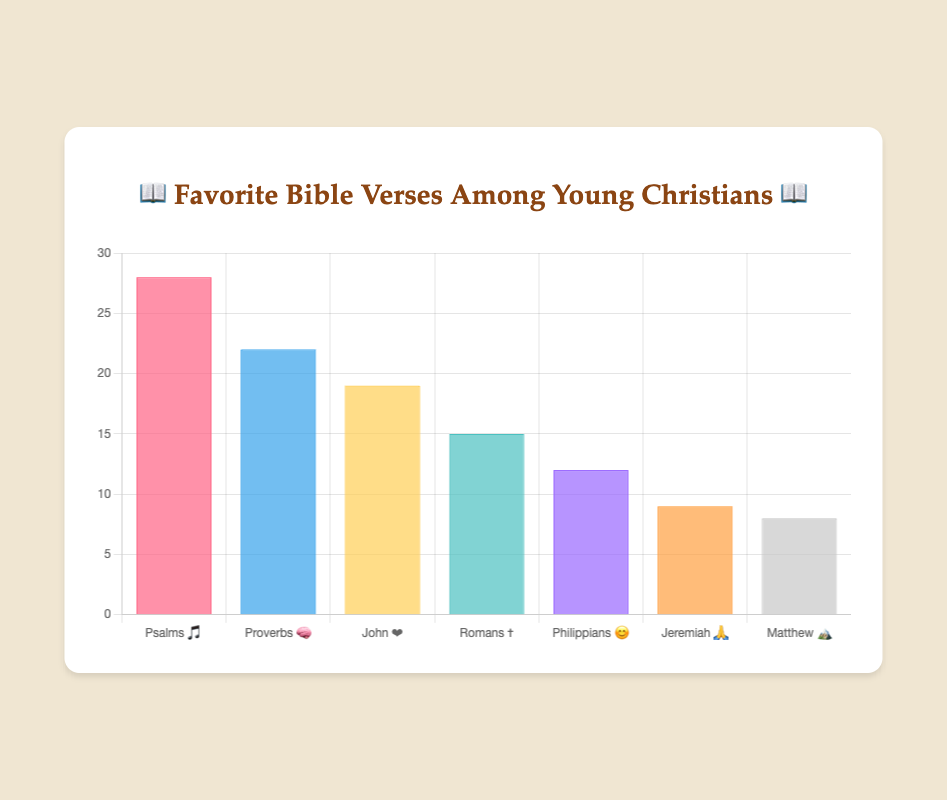Which book has the most favorite verses among young Christians? The book with the highest value on the chart represents the book with the most favorite verses. Psalms has the highest bar with 28 favorite verses.
Answer: Psalms 🎵 How many more favorite verses does Psalms have compared to Proverbs? Find the value for Psalms (28) and subtract the value for Proverbs (22). The difference is 28 - 22 = 6.
Answer: 6 Which book has the fewest favorite verses among the listed books? Identify the book with the shortest bar in the chart. Matthew has the shortest bar with 8 favorite verses.
Answer: Matthew 🏔️ What is the combined total of favorite verses for John and Romans? Look at the number of favorite verses for John (19) and Romans (15), then add them together. The combined total is 19 + 15 = 34.
Answer: 34 Is the number of favorite verses for Philippians closer to the number of favorite verses for Jeremiah or Matthew? Compare the difference between Philippians (12) and Jeremiah (9), and Philippians (12) and Matthew (8). The differences are 12 - 9 = 3 and 12 - 8 = 4. Philippians is closer to Jeremiah.
Answer: Jeremiah 🙏 What is the average number of favorite verses for all the listed books? Add up all the values (28 + 22 + 19 + 15 + 12 + 9 + 8) and divide by the number of books (7). The sum is 113, and the average is 113 / 7 = 16.14.
Answer: 16.14 Does Proverbs have more than twice the number of favorite verses as Matthew? Compare two times the value of Matthew (2 * 8 = 16) with the value of Proverbs (22). Proverbs (22) is greater than 16, so it has more than twice the favorite verses.
Answer: Yes Which two books have the same second and third highest number of favorite verses? Identify the second (Proverbs with 22) and third (John with 19) highest bars in the chart.
Answer: Proverbs 🧠 and John ❤️ What is the difference in the number of favorite verses between the book with the highest and lowest values? Subtract the number of favorite verses of the lowest book (Matthew with 8) from the highest (Psalms with 28). The difference is 28 - 8 = 20.
Answer: 20 